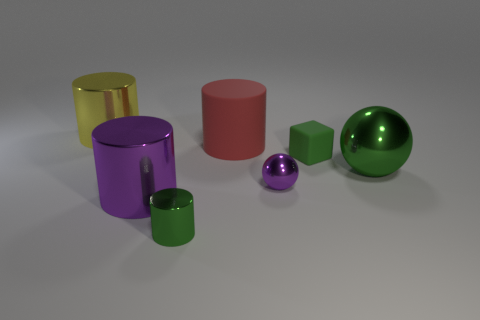There is a large ball that is the same color as the matte cube; what material is it?
Your answer should be compact. Metal. How many other things are there of the same color as the tiny cylinder?
Provide a succinct answer. 2. Are there any blue cylinders that have the same material as the large purple cylinder?
Make the answer very short. No. There is a small metal object that is behind the green metal object to the left of the tiny green thing behind the small purple sphere; what shape is it?
Provide a short and direct response. Sphere. Is the color of the small metallic thing that is on the left side of the large matte cylinder the same as the big metal cylinder that is in front of the tiny ball?
Make the answer very short. No. Is there any other thing that has the same size as the yellow cylinder?
Provide a succinct answer. Yes. There is a large yellow cylinder; are there any red cylinders behind it?
Your answer should be compact. No. What number of other large shiny things have the same shape as the yellow metal object?
Your answer should be very brief. 1. What color is the large metallic cylinder in front of the big cylinder left of the large metallic cylinder that is in front of the yellow metallic object?
Give a very brief answer. Purple. Are the big thing that is right of the big rubber object and the small thing behind the green metallic ball made of the same material?
Make the answer very short. No. 